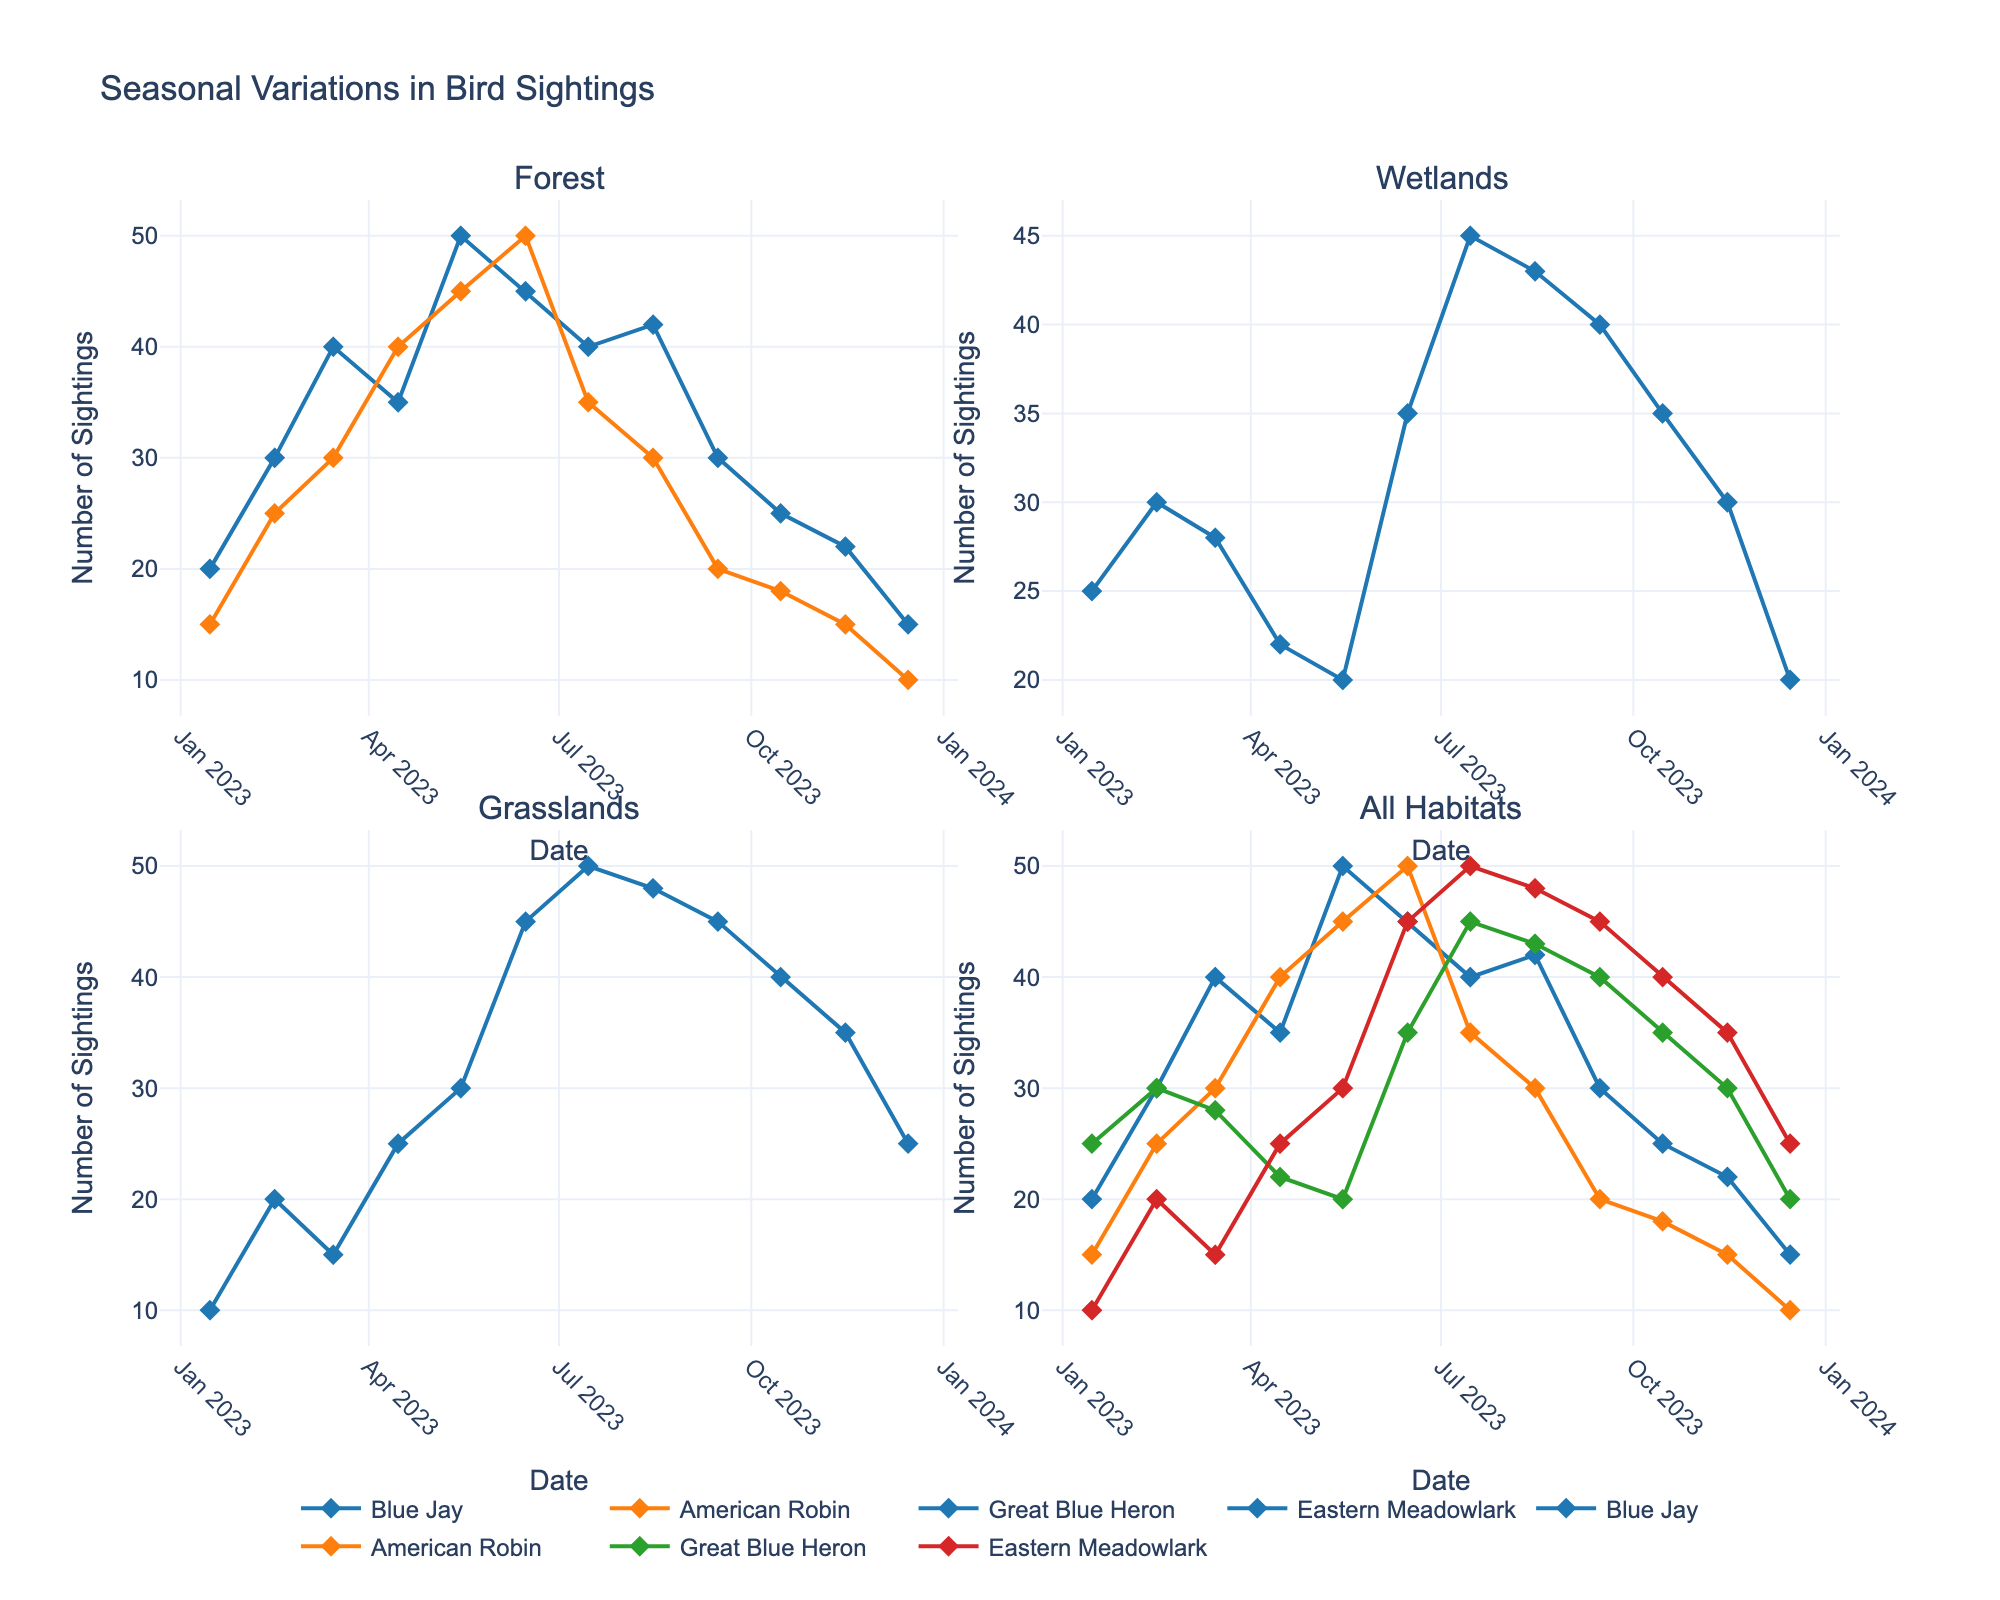What is the highest number of Blue Jay sightings in the Forest habitat? According to the figure, the peak number of Blue Jay sightings in the Forest occurred in May, with a total of 50 sightings.
Answer: 50 During which month were the American Robin sightings the highest in the Forest habitat? The figure shows that American Robin sightings in the Forest peaked in June, with a total of 50 sightings.
Answer: June Compare the number of Great Blue Heron sightings in February and May in the Wetlands habitat. Which month had more sightings? In February, there were 30 sightings of the Great Blue Heron, while in May, there were only 20 sightings. Thus, February had more sightings than May.
Answer: February What is the common trend of Eastern Meadowlark sightings in the Grasslands habitat throughout the year? Viewing the figure, Eastern Meadowlark sightings in Grasslands show a noticeable increase from January through July, with a peak in July, and then a gradual decrease from August to December.
Answer: Increase, then decrease Which habitat shows the most significant seasonal variation in bird sightings? By comparing the plots, Grasslands show the most significant seasonal variation, with the range of sightings for Eastern Meadowlark varying from 10 in January to 50 in July.
Answer: Grasslands 